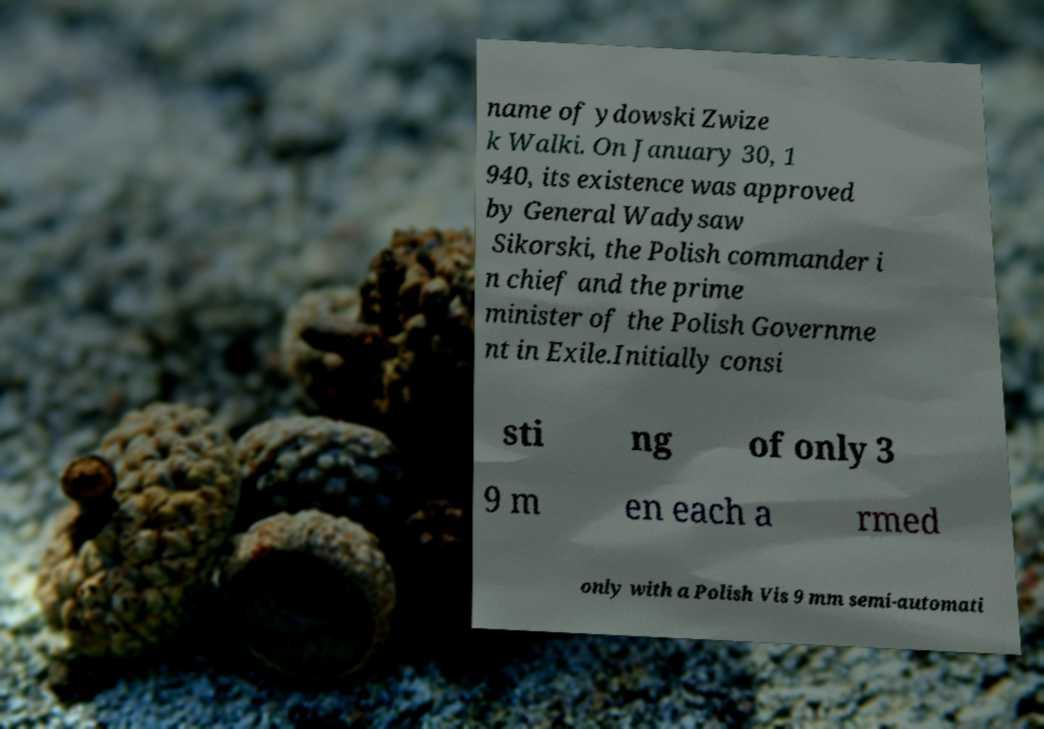Please identify and transcribe the text found in this image. name of ydowski Zwize k Walki. On January 30, 1 940, its existence was approved by General Wadysaw Sikorski, the Polish commander i n chief and the prime minister of the Polish Governme nt in Exile.Initially consi sti ng of only 3 9 m en each a rmed only with a Polish Vis 9 mm semi-automati 